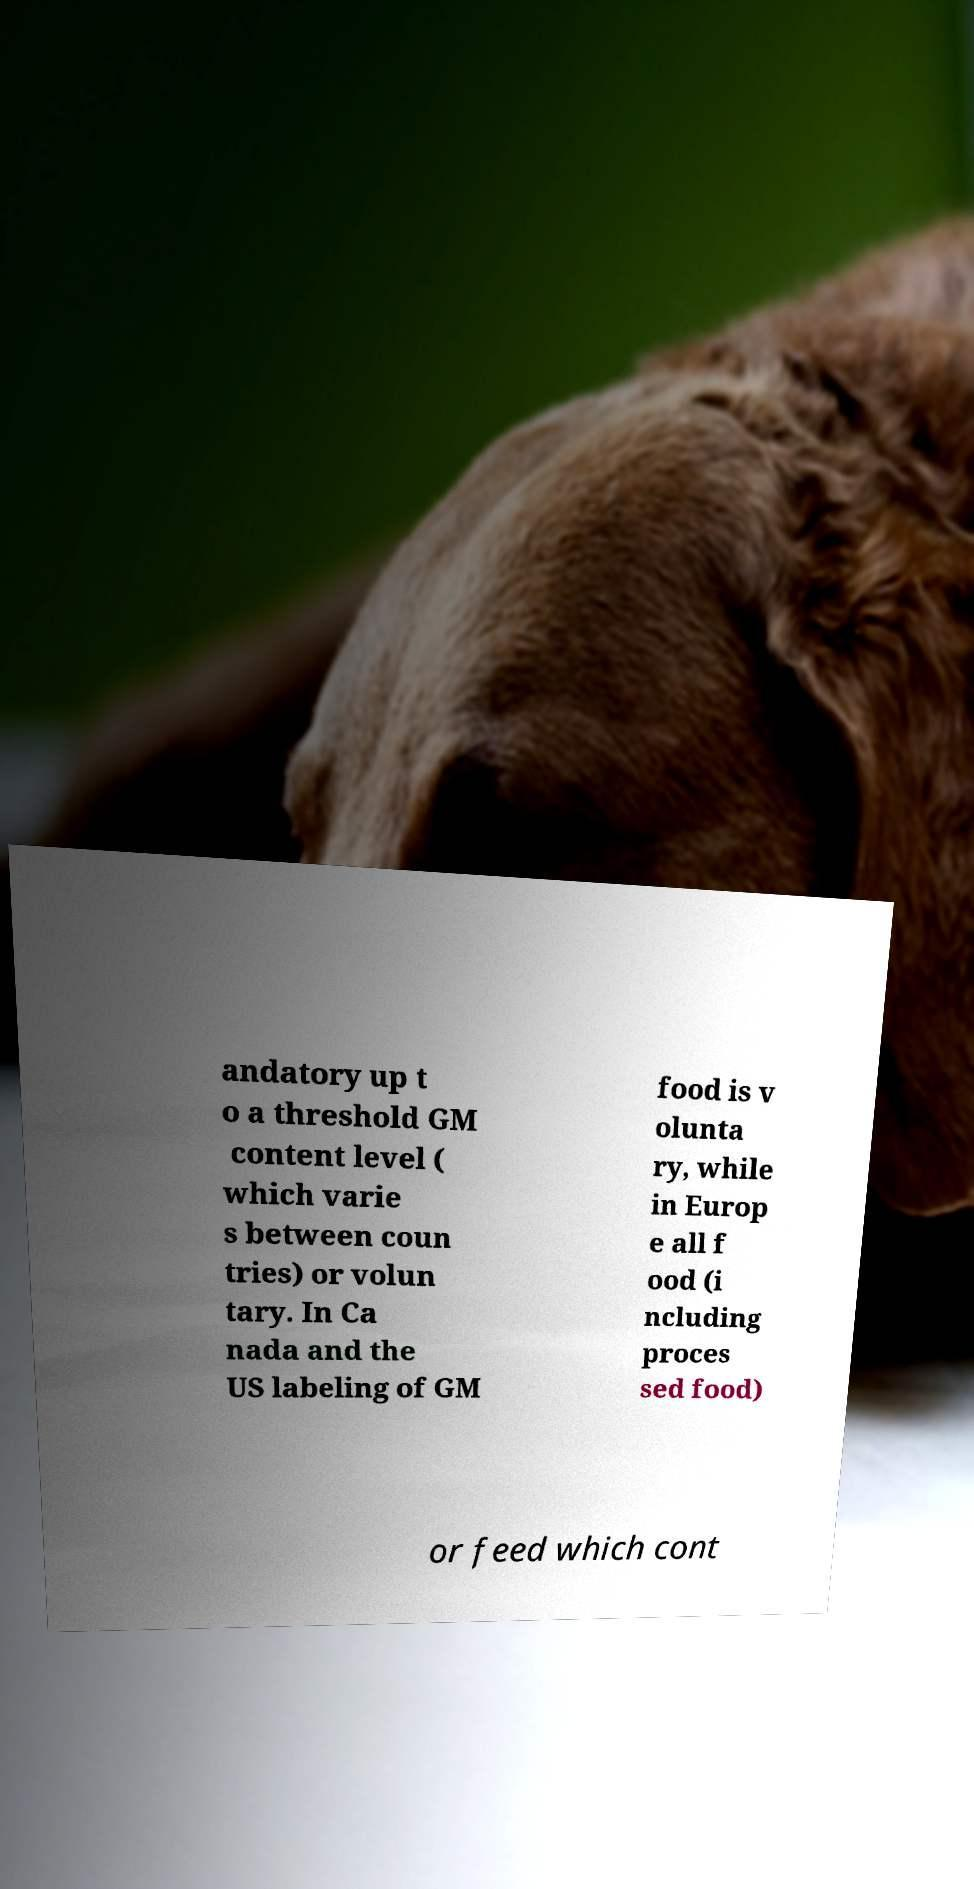Please read and relay the text visible in this image. What does it say? andatory up t o a threshold GM content level ( which varie s between coun tries) or volun tary. In Ca nada and the US labeling of GM food is v olunta ry, while in Europ e all f ood (i ncluding proces sed food) or feed which cont 